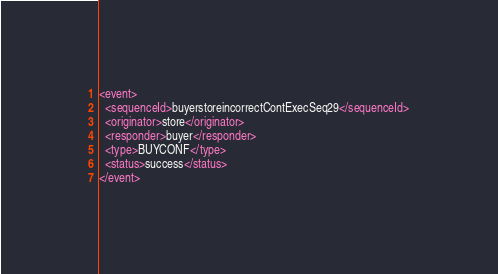Convert code to text. <code><loc_0><loc_0><loc_500><loc_500><_XML_><event>
  <sequenceId>buyerstoreincorrectContExecSeq29</sequenceId>
  <originator>store</originator>
  <responder>buyer</responder>
  <type>BUYCONF</type>
  <status>success</status>
</event>
</code> 